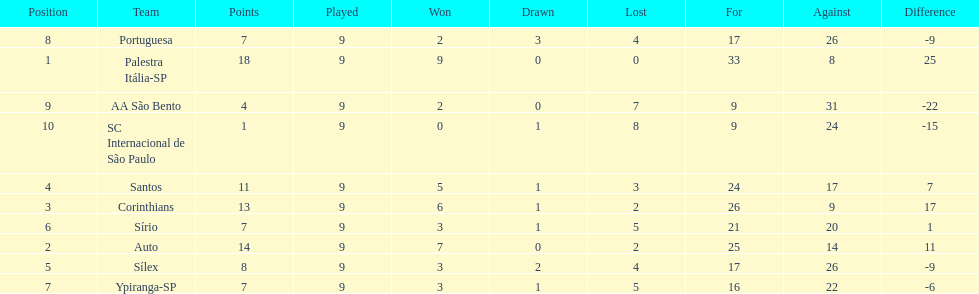Which brazilian team took the top spot in the 1926 brazilian football cup? Palestra Itália-SP. 